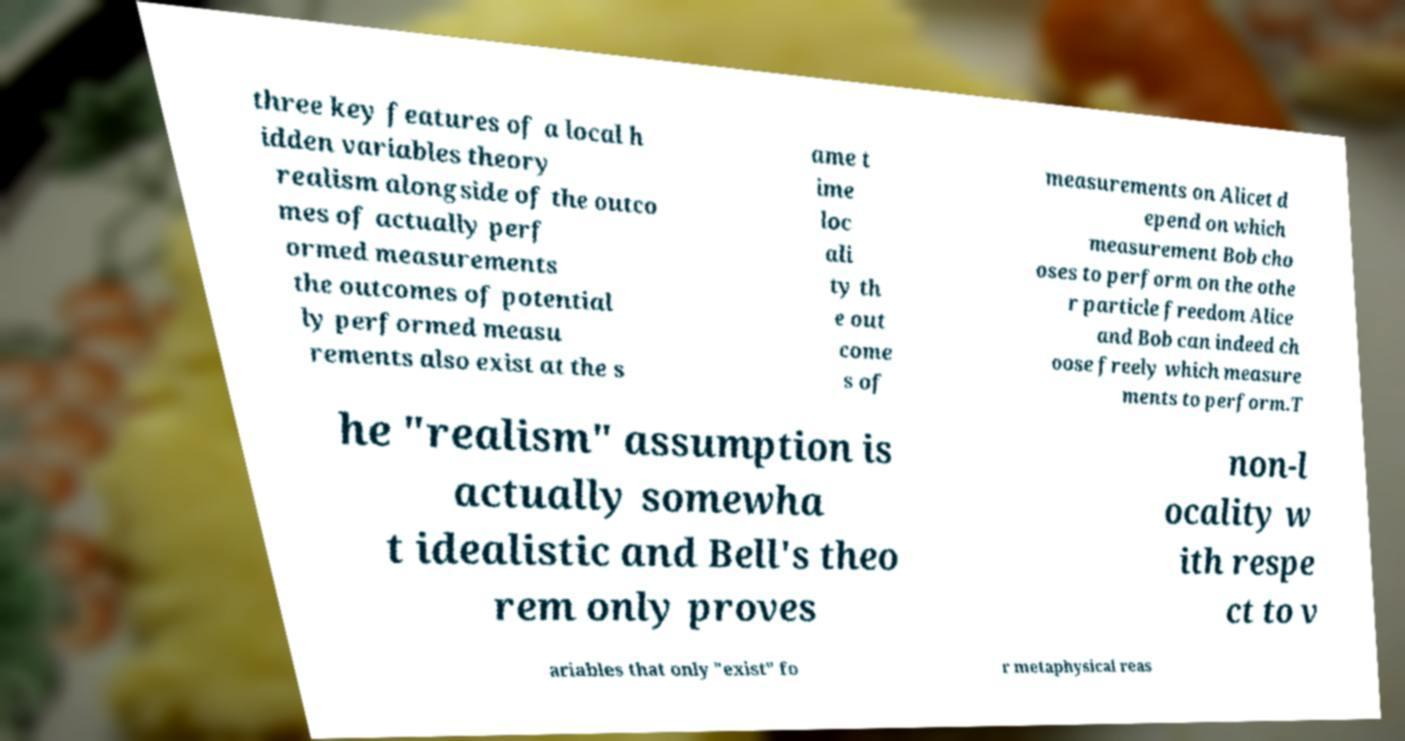Can you read and provide the text displayed in the image?This photo seems to have some interesting text. Can you extract and type it out for me? three key features of a local h idden variables theory realism alongside of the outco mes of actually perf ormed measurements the outcomes of potential ly performed measu rements also exist at the s ame t ime loc ali ty th e out come s of measurements on Alicet d epend on which measurement Bob cho oses to perform on the othe r particle freedom Alice and Bob can indeed ch oose freely which measure ments to perform.T he "realism" assumption is actually somewha t idealistic and Bell's theo rem only proves non-l ocality w ith respe ct to v ariables that only "exist" fo r metaphysical reas 